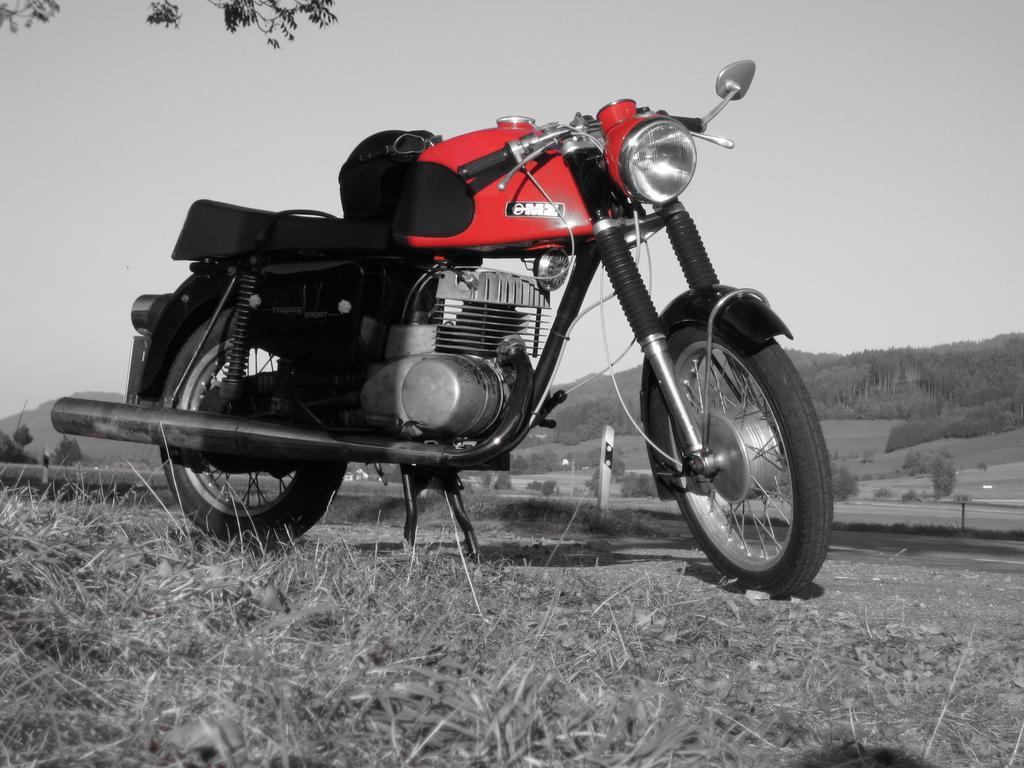Please provide a concise description of this image. Here in this picture we can see a motorbike present on a ground, which is fully covered with grass over there and in the far we can see mountains covered with plants and grass and we can see trees here and there. 